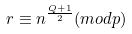Convert formula to latex. <formula><loc_0><loc_0><loc_500><loc_500>r \equiv n ^ { \frac { Q + 1 } { 2 } } ( m o d p )</formula> 